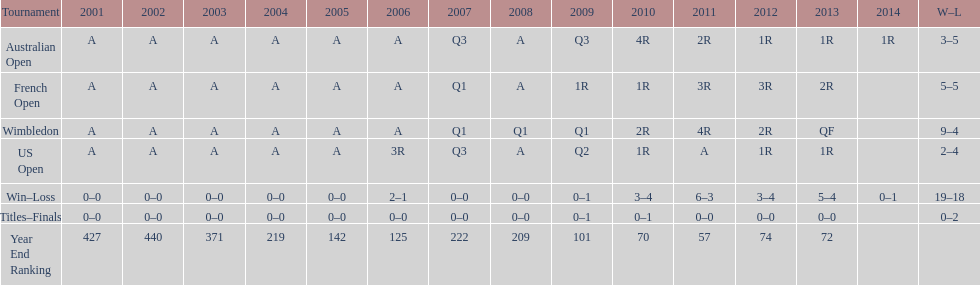Between 2001 and 2006, what was the average position of this participant? 287. 